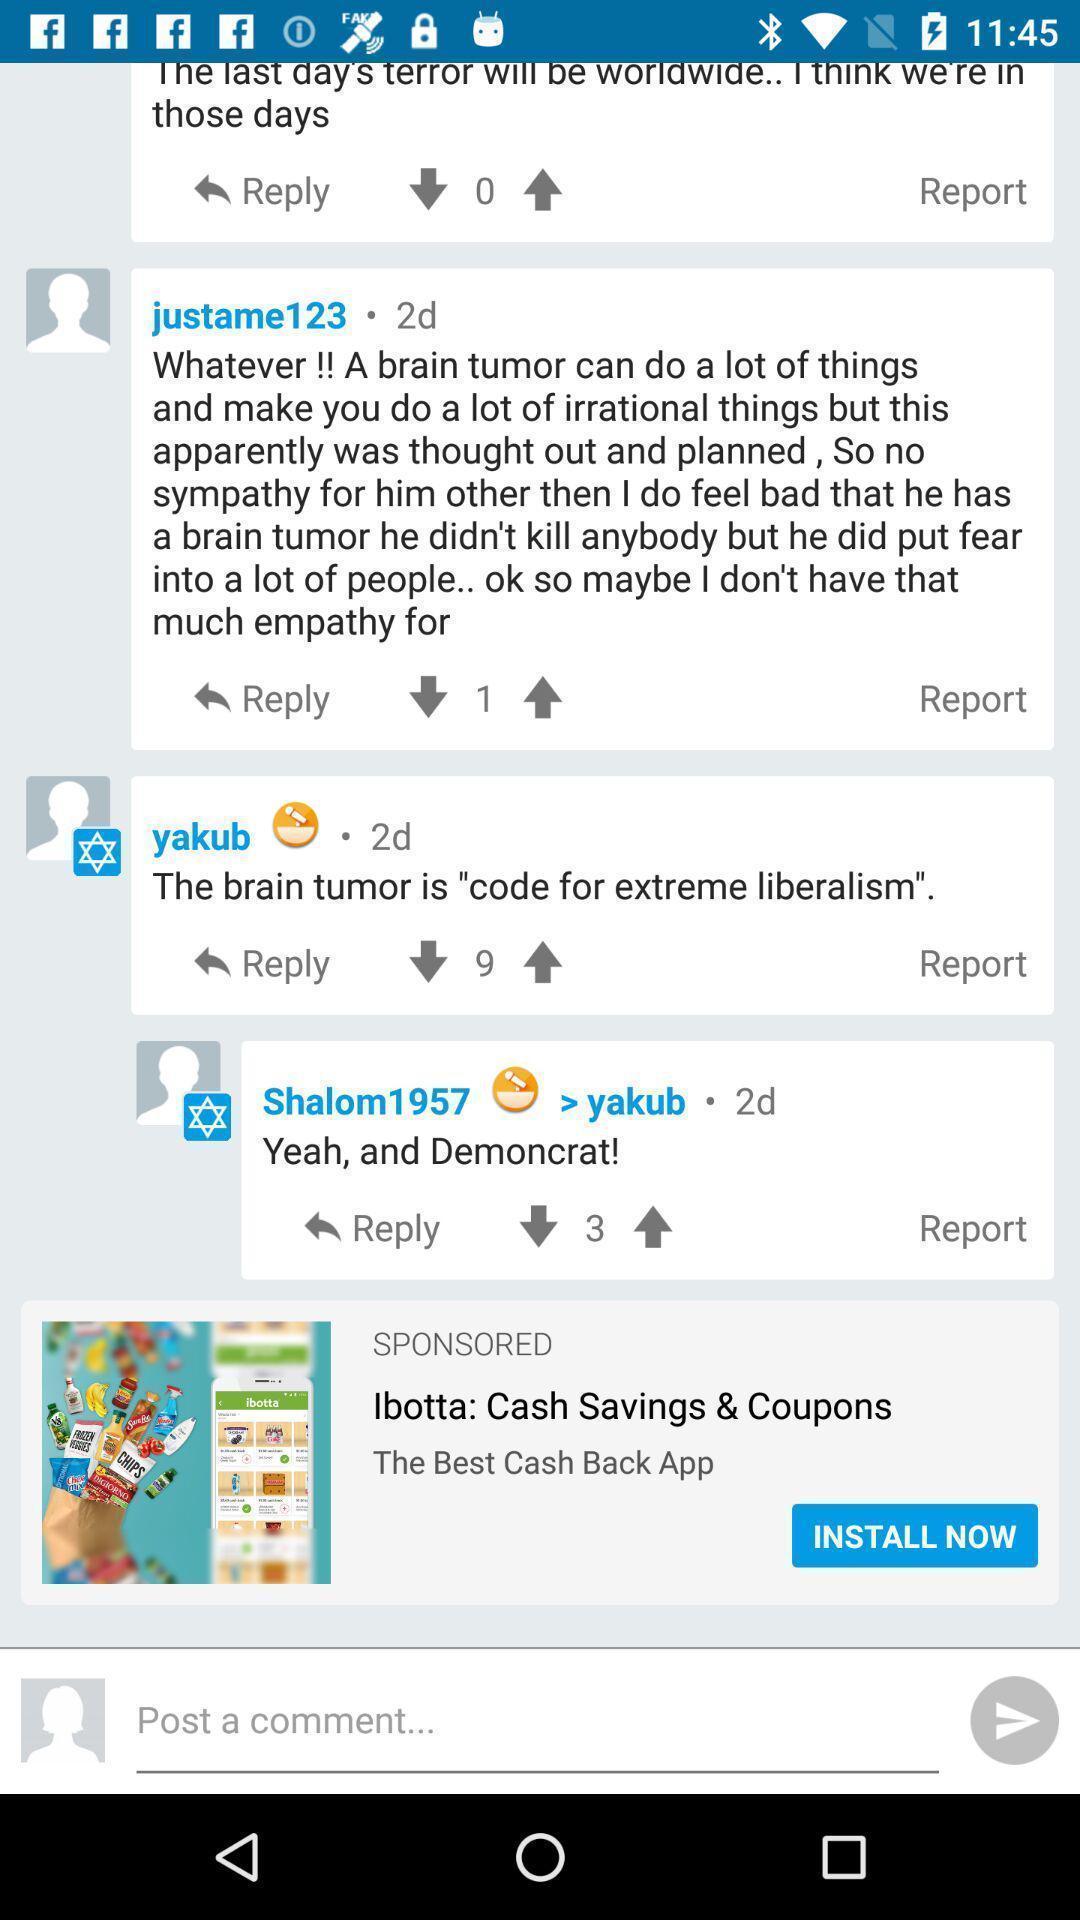Provide a detailed account of this screenshot. Screen shows comments page in news app. 